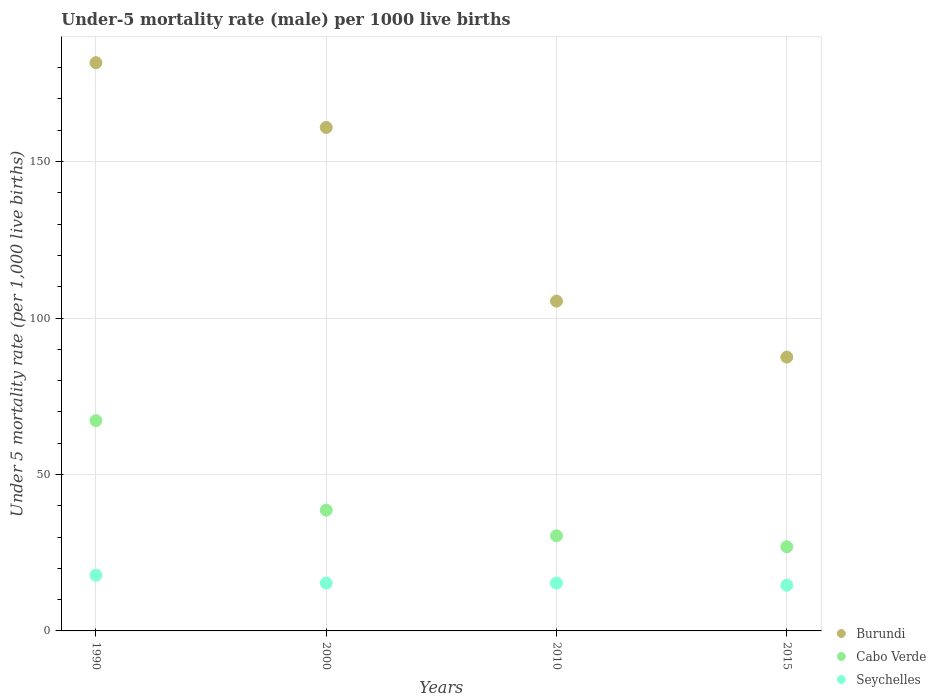How many different coloured dotlines are there?
Keep it short and to the point. 3. Is the number of dotlines equal to the number of legend labels?
Make the answer very short. Yes. What is the under-five mortality rate in Cabo Verde in 1990?
Your answer should be compact. 67.2. Across all years, what is the maximum under-five mortality rate in Burundi?
Make the answer very short. 181.6. Across all years, what is the minimum under-five mortality rate in Seychelles?
Offer a very short reply. 14.6. In which year was the under-five mortality rate in Burundi maximum?
Ensure brevity in your answer.  1990. In which year was the under-five mortality rate in Burundi minimum?
Make the answer very short. 2015. What is the total under-five mortality rate in Seychelles in the graph?
Your answer should be very brief. 63. What is the difference between the under-five mortality rate in Burundi in 1990 and that in 2015?
Offer a very short reply. 94.1. What is the difference between the under-five mortality rate in Seychelles in 2000 and the under-five mortality rate in Burundi in 2010?
Your answer should be compact. -90.1. What is the average under-five mortality rate in Cabo Verde per year?
Your answer should be very brief. 40.78. In the year 2015, what is the difference between the under-five mortality rate in Cabo Verde and under-five mortality rate in Burundi?
Ensure brevity in your answer.  -60.6. What is the ratio of the under-five mortality rate in Cabo Verde in 2000 to that in 2015?
Make the answer very short. 1.43. Is the difference between the under-five mortality rate in Cabo Verde in 1990 and 2000 greater than the difference between the under-five mortality rate in Burundi in 1990 and 2000?
Offer a terse response. Yes. What is the difference between the highest and the second highest under-five mortality rate in Burundi?
Ensure brevity in your answer.  20.7. What is the difference between the highest and the lowest under-five mortality rate in Seychelles?
Offer a very short reply. 3.2. In how many years, is the under-five mortality rate in Seychelles greater than the average under-five mortality rate in Seychelles taken over all years?
Offer a terse response. 1. Is the sum of the under-five mortality rate in Burundi in 1990 and 2010 greater than the maximum under-five mortality rate in Cabo Verde across all years?
Your answer should be very brief. Yes. Does the under-five mortality rate in Burundi monotonically increase over the years?
Provide a succinct answer. No. Are the values on the major ticks of Y-axis written in scientific E-notation?
Your answer should be very brief. No. Where does the legend appear in the graph?
Provide a short and direct response. Bottom right. What is the title of the graph?
Provide a succinct answer. Under-5 mortality rate (male) per 1000 live births. What is the label or title of the Y-axis?
Your response must be concise. Under 5 mortality rate (per 1,0 live births). What is the Under 5 mortality rate (per 1,000 live births) in Burundi in 1990?
Your response must be concise. 181.6. What is the Under 5 mortality rate (per 1,000 live births) in Cabo Verde in 1990?
Your answer should be very brief. 67.2. What is the Under 5 mortality rate (per 1,000 live births) of Seychelles in 1990?
Your answer should be very brief. 17.8. What is the Under 5 mortality rate (per 1,000 live births) of Burundi in 2000?
Provide a succinct answer. 160.9. What is the Under 5 mortality rate (per 1,000 live births) of Cabo Verde in 2000?
Ensure brevity in your answer.  38.6. What is the Under 5 mortality rate (per 1,000 live births) in Burundi in 2010?
Ensure brevity in your answer.  105.4. What is the Under 5 mortality rate (per 1,000 live births) in Cabo Verde in 2010?
Give a very brief answer. 30.4. What is the Under 5 mortality rate (per 1,000 live births) in Burundi in 2015?
Provide a short and direct response. 87.5. What is the Under 5 mortality rate (per 1,000 live births) in Cabo Verde in 2015?
Provide a short and direct response. 26.9. What is the Under 5 mortality rate (per 1,000 live births) in Seychelles in 2015?
Provide a short and direct response. 14.6. Across all years, what is the maximum Under 5 mortality rate (per 1,000 live births) of Burundi?
Offer a very short reply. 181.6. Across all years, what is the maximum Under 5 mortality rate (per 1,000 live births) in Cabo Verde?
Offer a terse response. 67.2. Across all years, what is the maximum Under 5 mortality rate (per 1,000 live births) in Seychelles?
Offer a terse response. 17.8. Across all years, what is the minimum Under 5 mortality rate (per 1,000 live births) in Burundi?
Keep it short and to the point. 87.5. Across all years, what is the minimum Under 5 mortality rate (per 1,000 live births) of Cabo Verde?
Give a very brief answer. 26.9. What is the total Under 5 mortality rate (per 1,000 live births) in Burundi in the graph?
Your answer should be compact. 535.4. What is the total Under 5 mortality rate (per 1,000 live births) in Cabo Verde in the graph?
Your response must be concise. 163.1. What is the difference between the Under 5 mortality rate (per 1,000 live births) of Burundi in 1990 and that in 2000?
Offer a terse response. 20.7. What is the difference between the Under 5 mortality rate (per 1,000 live births) in Cabo Verde in 1990 and that in 2000?
Ensure brevity in your answer.  28.6. What is the difference between the Under 5 mortality rate (per 1,000 live births) of Burundi in 1990 and that in 2010?
Provide a short and direct response. 76.2. What is the difference between the Under 5 mortality rate (per 1,000 live births) in Cabo Verde in 1990 and that in 2010?
Give a very brief answer. 36.8. What is the difference between the Under 5 mortality rate (per 1,000 live births) in Burundi in 1990 and that in 2015?
Provide a succinct answer. 94.1. What is the difference between the Under 5 mortality rate (per 1,000 live births) of Cabo Verde in 1990 and that in 2015?
Your answer should be compact. 40.3. What is the difference between the Under 5 mortality rate (per 1,000 live births) in Burundi in 2000 and that in 2010?
Your response must be concise. 55.5. What is the difference between the Under 5 mortality rate (per 1,000 live births) in Burundi in 2000 and that in 2015?
Ensure brevity in your answer.  73.4. What is the difference between the Under 5 mortality rate (per 1,000 live births) of Burundi in 1990 and the Under 5 mortality rate (per 1,000 live births) of Cabo Verde in 2000?
Ensure brevity in your answer.  143. What is the difference between the Under 5 mortality rate (per 1,000 live births) in Burundi in 1990 and the Under 5 mortality rate (per 1,000 live births) in Seychelles in 2000?
Offer a very short reply. 166.3. What is the difference between the Under 5 mortality rate (per 1,000 live births) in Cabo Verde in 1990 and the Under 5 mortality rate (per 1,000 live births) in Seychelles in 2000?
Your response must be concise. 51.9. What is the difference between the Under 5 mortality rate (per 1,000 live births) of Burundi in 1990 and the Under 5 mortality rate (per 1,000 live births) of Cabo Verde in 2010?
Your response must be concise. 151.2. What is the difference between the Under 5 mortality rate (per 1,000 live births) of Burundi in 1990 and the Under 5 mortality rate (per 1,000 live births) of Seychelles in 2010?
Give a very brief answer. 166.3. What is the difference between the Under 5 mortality rate (per 1,000 live births) in Cabo Verde in 1990 and the Under 5 mortality rate (per 1,000 live births) in Seychelles in 2010?
Your answer should be compact. 51.9. What is the difference between the Under 5 mortality rate (per 1,000 live births) of Burundi in 1990 and the Under 5 mortality rate (per 1,000 live births) of Cabo Verde in 2015?
Your answer should be very brief. 154.7. What is the difference between the Under 5 mortality rate (per 1,000 live births) of Burundi in 1990 and the Under 5 mortality rate (per 1,000 live births) of Seychelles in 2015?
Make the answer very short. 167. What is the difference between the Under 5 mortality rate (per 1,000 live births) of Cabo Verde in 1990 and the Under 5 mortality rate (per 1,000 live births) of Seychelles in 2015?
Give a very brief answer. 52.6. What is the difference between the Under 5 mortality rate (per 1,000 live births) of Burundi in 2000 and the Under 5 mortality rate (per 1,000 live births) of Cabo Verde in 2010?
Your answer should be compact. 130.5. What is the difference between the Under 5 mortality rate (per 1,000 live births) of Burundi in 2000 and the Under 5 mortality rate (per 1,000 live births) of Seychelles in 2010?
Your answer should be compact. 145.6. What is the difference between the Under 5 mortality rate (per 1,000 live births) of Cabo Verde in 2000 and the Under 5 mortality rate (per 1,000 live births) of Seychelles in 2010?
Make the answer very short. 23.3. What is the difference between the Under 5 mortality rate (per 1,000 live births) of Burundi in 2000 and the Under 5 mortality rate (per 1,000 live births) of Cabo Verde in 2015?
Offer a terse response. 134. What is the difference between the Under 5 mortality rate (per 1,000 live births) in Burundi in 2000 and the Under 5 mortality rate (per 1,000 live births) in Seychelles in 2015?
Your answer should be compact. 146.3. What is the difference between the Under 5 mortality rate (per 1,000 live births) in Cabo Verde in 2000 and the Under 5 mortality rate (per 1,000 live births) in Seychelles in 2015?
Offer a very short reply. 24. What is the difference between the Under 5 mortality rate (per 1,000 live births) of Burundi in 2010 and the Under 5 mortality rate (per 1,000 live births) of Cabo Verde in 2015?
Your response must be concise. 78.5. What is the difference between the Under 5 mortality rate (per 1,000 live births) of Burundi in 2010 and the Under 5 mortality rate (per 1,000 live births) of Seychelles in 2015?
Provide a succinct answer. 90.8. What is the average Under 5 mortality rate (per 1,000 live births) in Burundi per year?
Your answer should be very brief. 133.85. What is the average Under 5 mortality rate (per 1,000 live births) of Cabo Verde per year?
Your response must be concise. 40.77. What is the average Under 5 mortality rate (per 1,000 live births) of Seychelles per year?
Your answer should be very brief. 15.75. In the year 1990, what is the difference between the Under 5 mortality rate (per 1,000 live births) in Burundi and Under 5 mortality rate (per 1,000 live births) in Cabo Verde?
Your answer should be compact. 114.4. In the year 1990, what is the difference between the Under 5 mortality rate (per 1,000 live births) in Burundi and Under 5 mortality rate (per 1,000 live births) in Seychelles?
Provide a short and direct response. 163.8. In the year 1990, what is the difference between the Under 5 mortality rate (per 1,000 live births) in Cabo Verde and Under 5 mortality rate (per 1,000 live births) in Seychelles?
Your answer should be very brief. 49.4. In the year 2000, what is the difference between the Under 5 mortality rate (per 1,000 live births) of Burundi and Under 5 mortality rate (per 1,000 live births) of Cabo Verde?
Ensure brevity in your answer.  122.3. In the year 2000, what is the difference between the Under 5 mortality rate (per 1,000 live births) in Burundi and Under 5 mortality rate (per 1,000 live births) in Seychelles?
Your answer should be compact. 145.6. In the year 2000, what is the difference between the Under 5 mortality rate (per 1,000 live births) of Cabo Verde and Under 5 mortality rate (per 1,000 live births) of Seychelles?
Give a very brief answer. 23.3. In the year 2010, what is the difference between the Under 5 mortality rate (per 1,000 live births) of Burundi and Under 5 mortality rate (per 1,000 live births) of Seychelles?
Make the answer very short. 90.1. In the year 2015, what is the difference between the Under 5 mortality rate (per 1,000 live births) of Burundi and Under 5 mortality rate (per 1,000 live births) of Cabo Verde?
Offer a very short reply. 60.6. In the year 2015, what is the difference between the Under 5 mortality rate (per 1,000 live births) in Burundi and Under 5 mortality rate (per 1,000 live births) in Seychelles?
Give a very brief answer. 72.9. What is the ratio of the Under 5 mortality rate (per 1,000 live births) of Burundi in 1990 to that in 2000?
Your answer should be very brief. 1.13. What is the ratio of the Under 5 mortality rate (per 1,000 live births) in Cabo Verde in 1990 to that in 2000?
Your answer should be very brief. 1.74. What is the ratio of the Under 5 mortality rate (per 1,000 live births) of Seychelles in 1990 to that in 2000?
Provide a short and direct response. 1.16. What is the ratio of the Under 5 mortality rate (per 1,000 live births) in Burundi in 1990 to that in 2010?
Ensure brevity in your answer.  1.72. What is the ratio of the Under 5 mortality rate (per 1,000 live births) in Cabo Verde in 1990 to that in 2010?
Give a very brief answer. 2.21. What is the ratio of the Under 5 mortality rate (per 1,000 live births) of Seychelles in 1990 to that in 2010?
Ensure brevity in your answer.  1.16. What is the ratio of the Under 5 mortality rate (per 1,000 live births) of Burundi in 1990 to that in 2015?
Provide a succinct answer. 2.08. What is the ratio of the Under 5 mortality rate (per 1,000 live births) of Cabo Verde in 1990 to that in 2015?
Your answer should be very brief. 2.5. What is the ratio of the Under 5 mortality rate (per 1,000 live births) of Seychelles in 1990 to that in 2015?
Provide a succinct answer. 1.22. What is the ratio of the Under 5 mortality rate (per 1,000 live births) of Burundi in 2000 to that in 2010?
Keep it short and to the point. 1.53. What is the ratio of the Under 5 mortality rate (per 1,000 live births) of Cabo Verde in 2000 to that in 2010?
Your answer should be compact. 1.27. What is the ratio of the Under 5 mortality rate (per 1,000 live births) of Burundi in 2000 to that in 2015?
Provide a short and direct response. 1.84. What is the ratio of the Under 5 mortality rate (per 1,000 live births) of Cabo Verde in 2000 to that in 2015?
Your answer should be very brief. 1.43. What is the ratio of the Under 5 mortality rate (per 1,000 live births) in Seychelles in 2000 to that in 2015?
Provide a short and direct response. 1.05. What is the ratio of the Under 5 mortality rate (per 1,000 live births) of Burundi in 2010 to that in 2015?
Your answer should be compact. 1.2. What is the ratio of the Under 5 mortality rate (per 1,000 live births) of Cabo Verde in 2010 to that in 2015?
Make the answer very short. 1.13. What is the ratio of the Under 5 mortality rate (per 1,000 live births) of Seychelles in 2010 to that in 2015?
Offer a very short reply. 1.05. What is the difference between the highest and the second highest Under 5 mortality rate (per 1,000 live births) in Burundi?
Ensure brevity in your answer.  20.7. What is the difference between the highest and the second highest Under 5 mortality rate (per 1,000 live births) of Cabo Verde?
Provide a short and direct response. 28.6. What is the difference between the highest and the second highest Under 5 mortality rate (per 1,000 live births) of Seychelles?
Make the answer very short. 2.5. What is the difference between the highest and the lowest Under 5 mortality rate (per 1,000 live births) in Burundi?
Ensure brevity in your answer.  94.1. What is the difference between the highest and the lowest Under 5 mortality rate (per 1,000 live births) of Cabo Verde?
Make the answer very short. 40.3. 